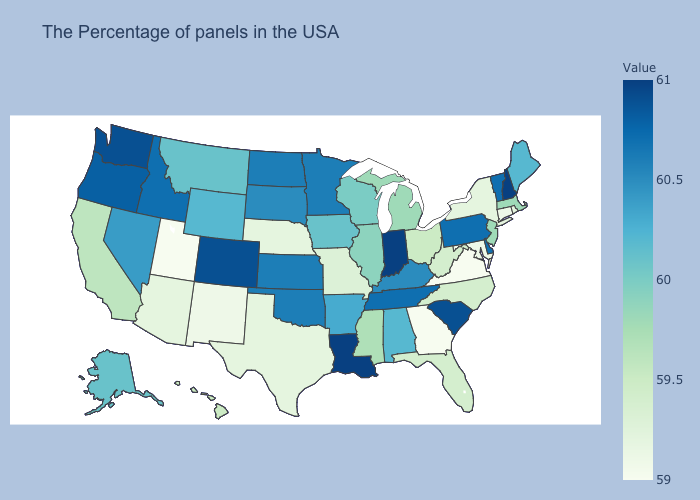Does Wyoming have the lowest value in the West?
Short answer required. No. Is the legend a continuous bar?
Answer briefly. Yes. Is the legend a continuous bar?
Be succinct. Yes. Does the map have missing data?
Answer briefly. No. Does Virginia have the lowest value in the USA?
Keep it brief. Yes. Does Oregon have the highest value in the West?
Be succinct. No. 